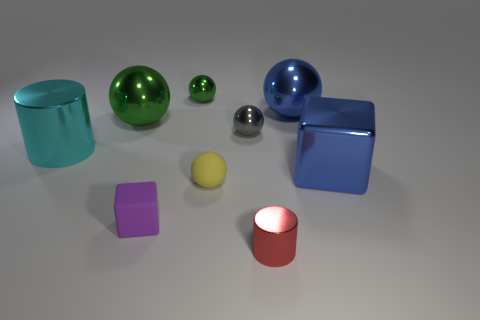Subtract 2 balls. How many balls are left? 3 Subtract all blue shiny spheres. How many spheres are left? 4 Subtract all red balls. Subtract all yellow cylinders. How many balls are left? 5 Subtract all blocks. How many objects are left? 7 Add 5 big cyan shiny cylinders. How many big cyan shiny cylinders exist? 6 Subtract 1 cyan cylinders. How many objects are left? 8 Subtract all large cyan objects. Subtract all rubber objects. How many objects are left? 6 Add 5 yellow matte spheres. How many yellow matte spheres are left? 6 